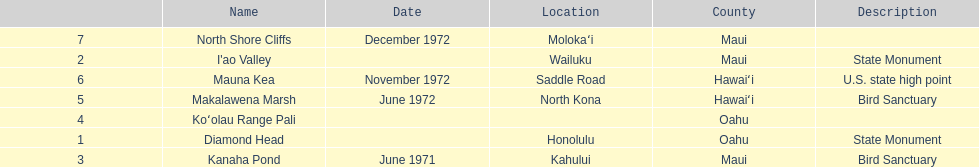How many locations are bird sanctuaries. 2. 